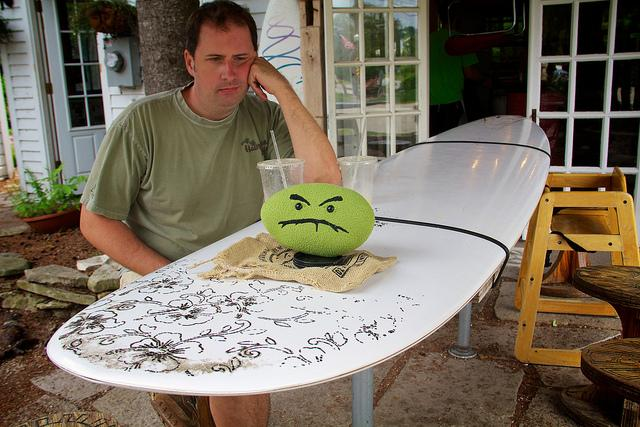What facial expression is the green ball showing? angry 